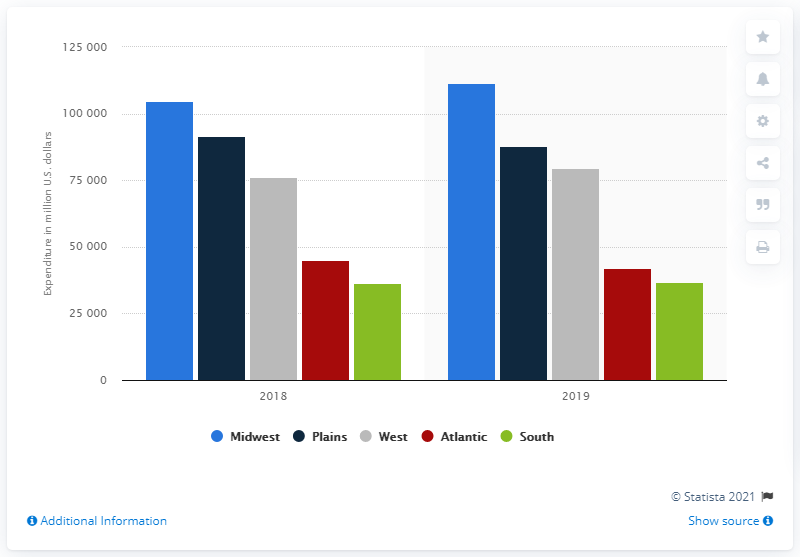List a handful of essential elements in this visual. In 2019, the total amount of farm production expenditures in the Midwest was 111,460. 